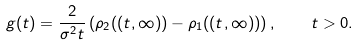Convert formula to latex. <formula><loc_0><loc_0><loc_500><loc_500>g ( t ) = \frac { 2 } { \sigma ^ { 2 } t } \left ( \rho _ { 2 } ( ( t , \infty ) ) - \rho _ { 1 } ( ( t , \infty ) ) \right ) , \quad t > 0 .</formula> 